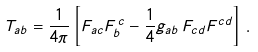Convert formula to latex. <formula><loc_0><loc_0><loc_500><loc_500>T _ { a b } = \frac { 1 } { 4 \pi } \left [ F _ { a c } F ^ { \, c } _ { b } - \frac { 1 } { 4 } g _ { a b } \, F _ { c d } F ^ { c d } \right ] \, .</formula> 